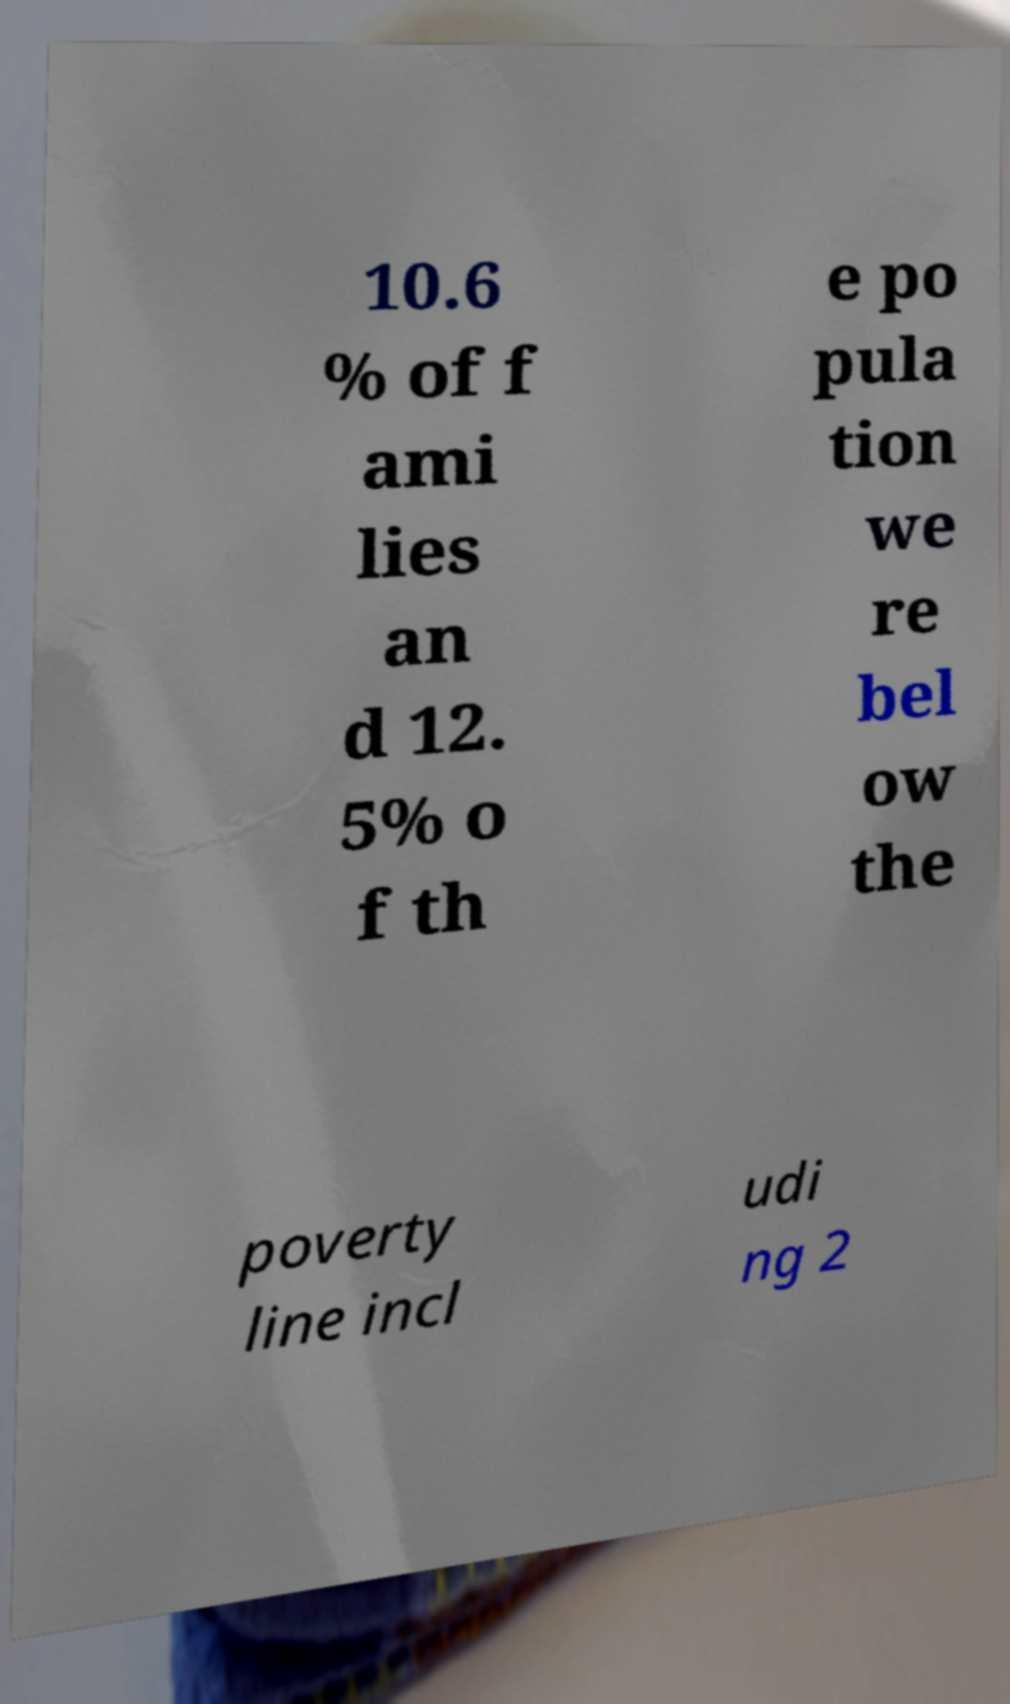I need the written content from this picture converted into text. Can you do that? 10.6 % of f ami lies an d 12. 5% o f th e po pula tion we re bel ow the poverty line incl udi ng 2 